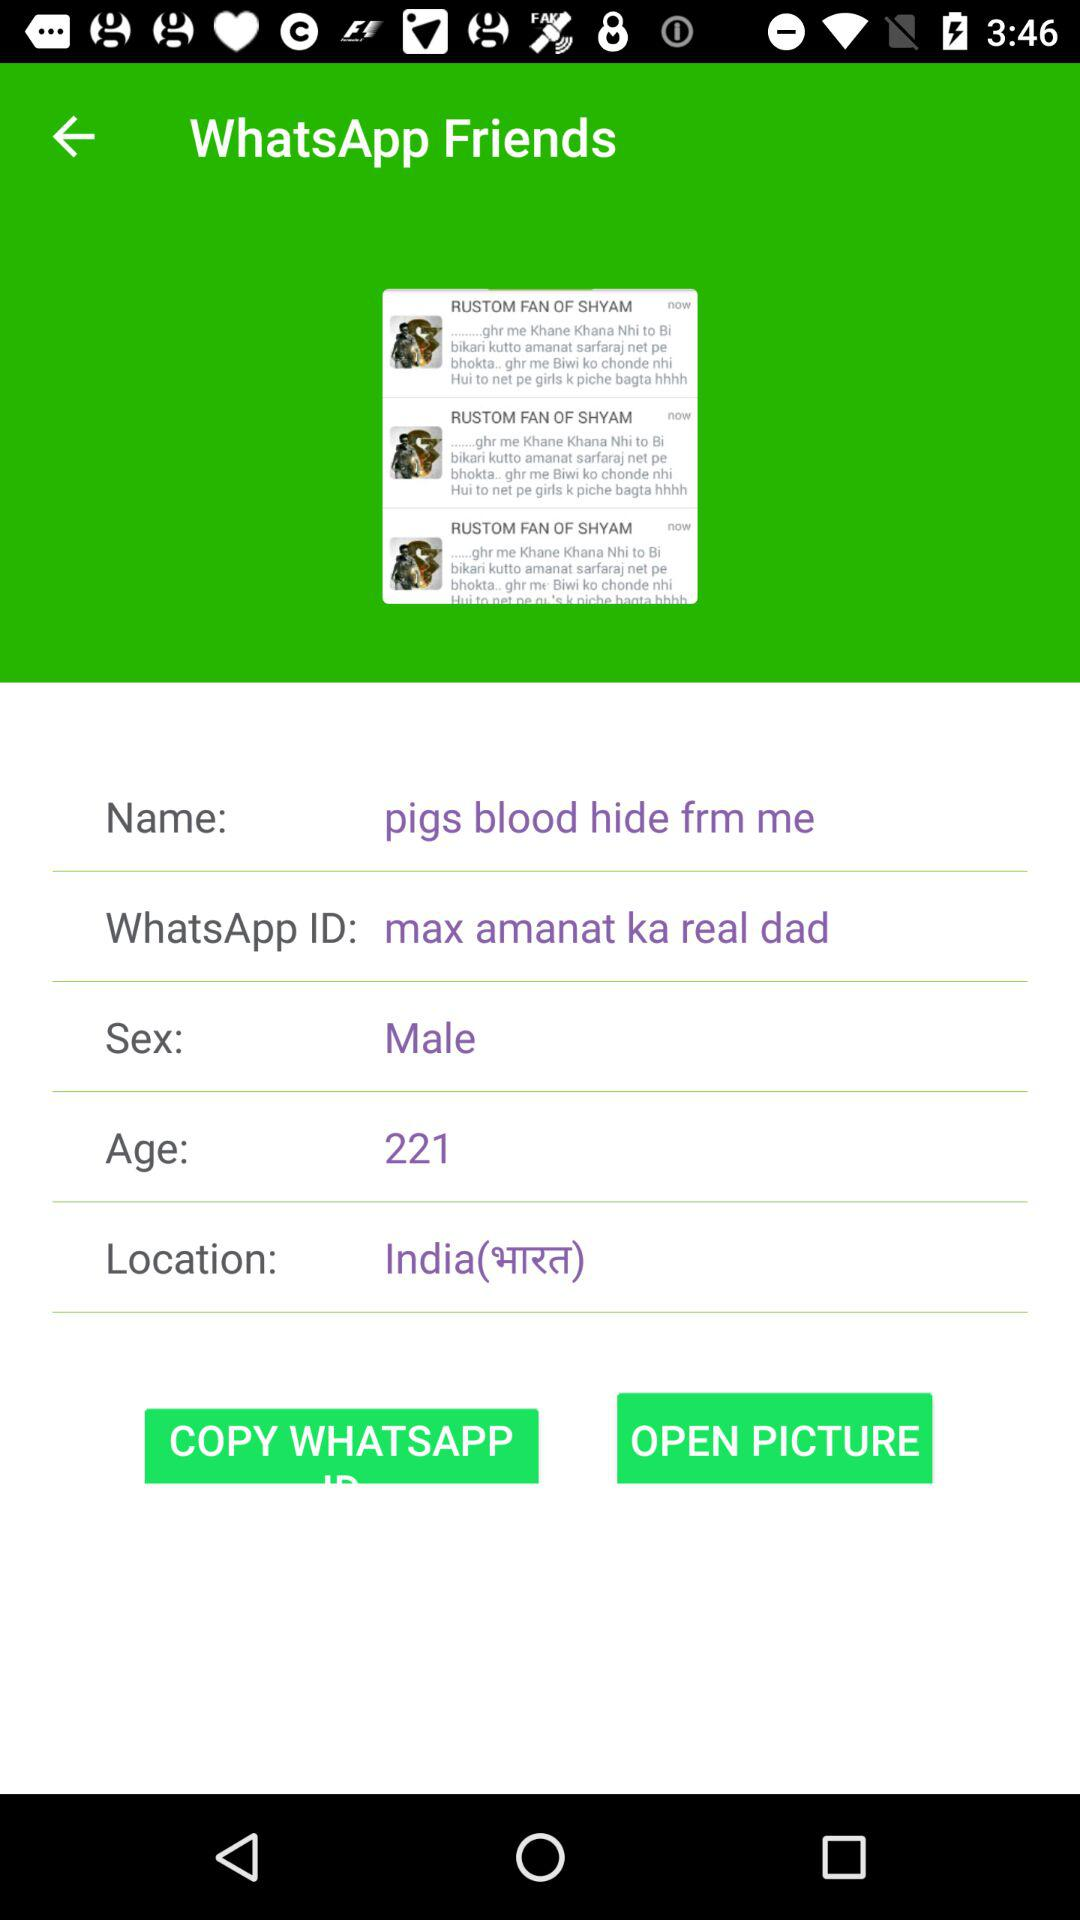What is the sex? The sex is male. 